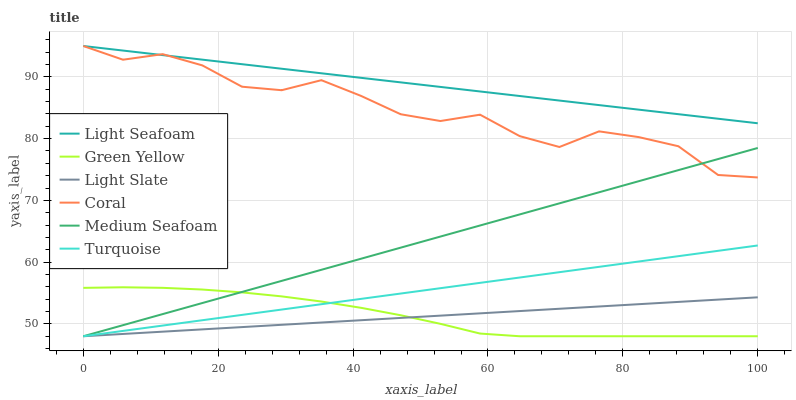Does Light Slate have the minimum area under the curve?
Answer yes or no. Yes. Does Light Seafoam have the maximum area under the curve?
Answer yes or no. Yes. Does Light Seafoam have the minimum area under the curve?
Answer yes or no. No. Does Light Slate have the maximum area under the curve?
Answer yes or no. No. Is Turquoise the smoothest?
Answer yes or no. Yes. Is Coral the roughest?
Answer yes or no. Yes. Is Light Seafoam the smoothest?
Answer yes or no. No. Is Light Seafoam the roughest?
Answer yes or no. No. Does Turquoise have the lowest value?
Answer yes or no. Yes. Does Light Seafoam have the lowest value?
Answer yes or no. No. Does Coral have the highest value?
Answer yes or no. Yes. Does Light Slate have the highest value?
Answer yes or no. No. Is Green Yellow less than Light Seafoam?
Answer yes or no. Yes. Is Light Seafoam greater than Medium Seafoam?
Answer yes or no. Yes. Does Turquoise intersect Green Yellow?
Answer yes or no. Yes. Is Turquoise less than Green Yellow?
Answer yes or no. No. Is Turquoise greater than Green Yellow?
Answer yes or no. No. Does Green Yellow intersect Light Seafoam?
Answer yes or no. No. 